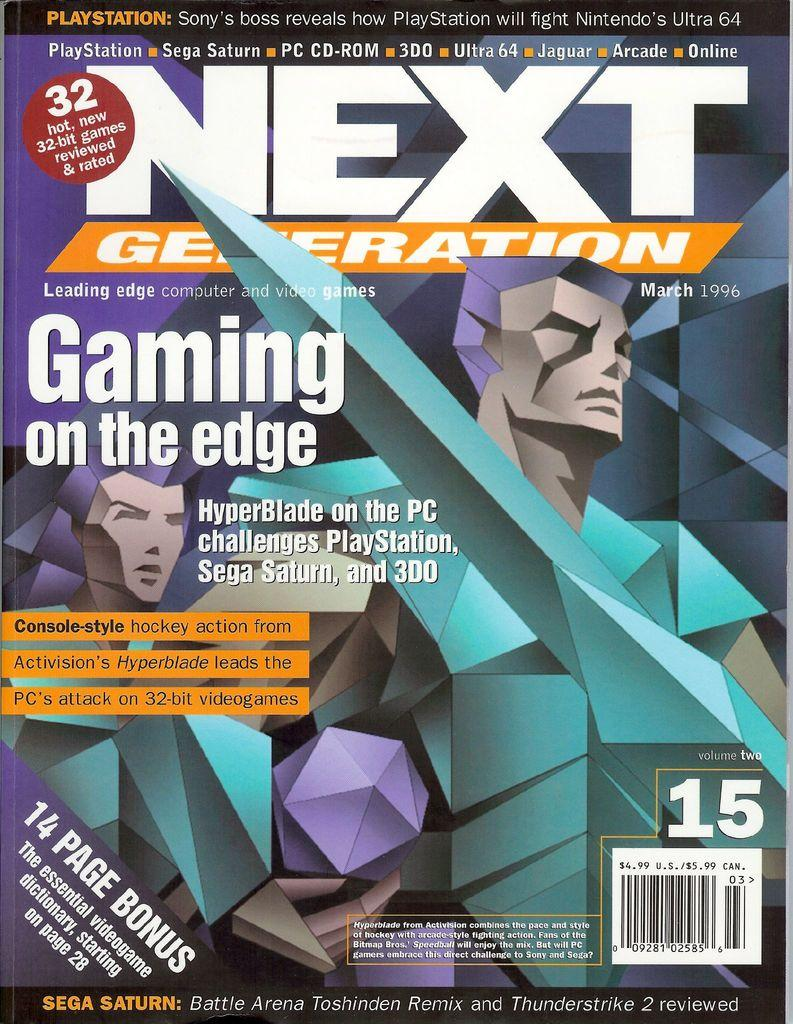Provide a one-sentence caption for the provided image. Next Generation magazine explores the subject of Gaming on the Edge. 